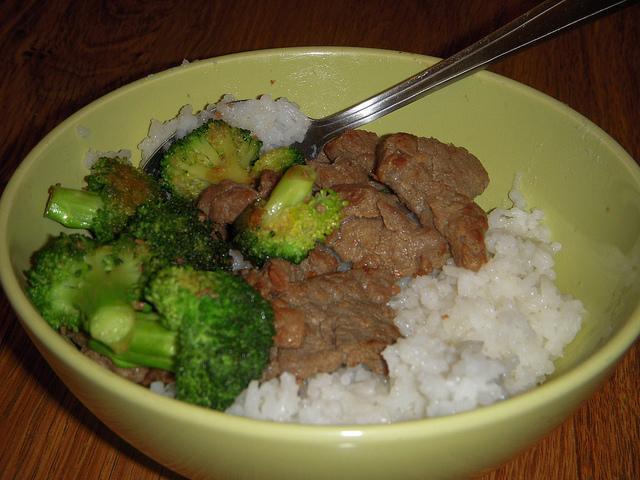How many pieces of broccoli are in the dish?
Give a very brief answer. 6. How many servings of carbohydrates are shown?
Give a very brief answer. 1. How many broccolis are visible?
Give a very brief answer. 2. How many people is wearing cap?
Give a very brief answer. 0. 